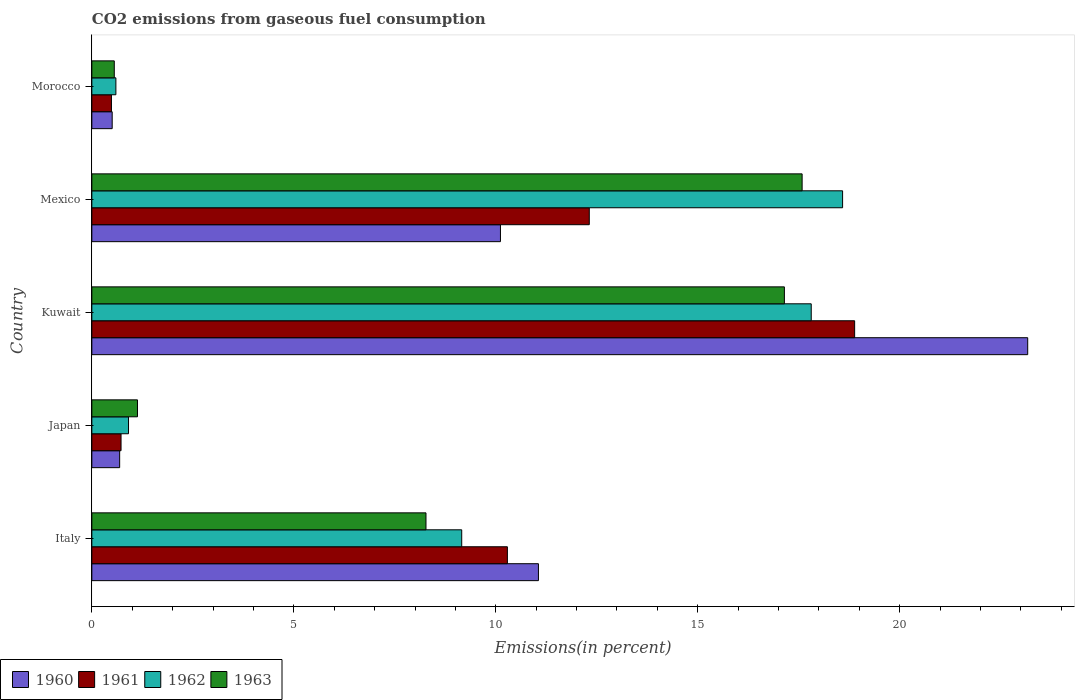How many bars are there on the 2nd tick from the bottom?
Give a very brief answer. 4. What is the label of the 2nd group of bars from the top?
Make the answer very short. Mexico. In how many cases, is the number of bars for a given country not equal to the number of legend labels?
Your response must be concise. 0. What is the total CO2 emitted in 1963 in Mexico?
Make the answer very short. 17.58. Across all countries, what is the maximum total CO2 emitted in 1960?
Keep it short and to the point. 23.17. Across all countries, what is the minimum total CO2 emitted in 1961?
Offer a very short reply. 0.49. In which country was the total CO2 emitted in 1962 minimum?
Ensure brevity in your answer.  Morocco. What is the total total CO2 emitted in 1960 in the graph?
Your response must be concise. 45.53. What is the difference between the total CO2 emitted in 1962 in Italy and that in Morocco?
Provide a short and direct response. 8.56. What is the difference between the total CO2 emitted in 1961 in Italy and the total CO2 emitted in 1960 in Kuwait?
Ensure brevity in your answer.  -12.88. What is the average total CO2 emitted in 1961 per country?
Ensure brevity in your answer.  8.54. What is the difference between the total CO2 emitted in 1963 and total CO2 emitted in 1962 in Japan?
Offer a very short reply. 0.22. What is the ratio of the total CO2 emitted in 1960 in Italy to that in Morocco?
Ensure brevity in your answer.  21.96. Is the total CO2 emitted in 1960 in Kuwait less than that in Morocco?
Your answer should be compact. No. What is the difference between the highest and the second highest total CO2 emitted in 1963?
Give a very brief answer. 0.44. What is the difference between the highest and the lowest total CO2 emitted in 1963?
Your answer should be very brief. 17.03. Is the sum of the total CO2 emitted in 1962 in Japan and Morocco greater than the maximum total CO2 emitted in 1961 across all countries?
Give a very brief answer. No. Is it the case that in every country, the sum of the total CO2 emitted in 1962 and total CO2 emitted in 1963 is greater than the sum of total CO2 emitted in 1961 and total CO2 emitted in 1960?
Offer a very short reply. No. How many bars are there?
Keep it short and to the point. 20. Are all the bars in the graph horizontal?
Your response must be concise. Yes. How many countries are there in the graph?
Provide a succinct answer. 5. Are the values on the major ticks of X-axis written in scientific E-notation?
Make the answer very short. No. Does the graph contain grids?
Ensure brevity in your answer.  No. Where does the legend appear in the graph?
Ensure brevity in your answer.  Bottom left. How many legend labels are there?
Your answer should be very brief. 4. What is the title of the graph?
Keep it short and to the point. CO2 emissions from gaseous fuel consumption. Does "1967" appear as one of the legend labels in the graph?
Provide a short and direct response. No. What is the label or title of the X-axis?
Offer a very short reply. Emissions(in percent). What is the Emissions(in percent) of 1960 in Italy?
Your answer should be compact. 11.06. What is the Emissions(in percent) in 1961 in Italy?
Your answer should be compact. 10.29. What is the Emissions(in percent) of 1962 in Italy?
Provide a succinct answer. 9.16. What is the Emissions(in percent) of 1963 in Italy?
Keep it short and to the point. 8.27. What is the Emissions(in percent) in 1960 in Japan?
Give a very brief answer. 0.69. What is the Emissions(in percent) of 1961 in Japan?
Your response must be concise. 0.72. What is the Emissions(in percent) in 1962 in Japan?
Provide a succinct answer. 0.91. What is the Emissions(in percent) in 1963 in Japan?
Keep it short and to the point. 1.13. What is the Emissions(in percent) of 1960 in Kuwait?
Provide a short and direct response. 23.17. What is the Emissions(in percent) in 1961 in Kuwait?
Provide a short and direct response. 18.88. What is the Emissions(in percent) of 1962 in Kuwait?
Offer a very short reply. 17.81. What is the Emissions(in percent) of 1963 in Kuwait?
Make the answer very short. 17.14. What is the Emissions(in percent) in 1960 in Mexico?
Offer a very short reply. 10.12. What is the Emissions(in percent) in 1961 in Mexico?
Your answer should be very brief. 12.31. What is the Emissions(in percent) in 1962 in Mexico?
Offer a terse response. 18.59. What is the Emissions(in percent) of 1963 in Mexico?
Provide a short and direct response. 17.58. What is the Emissions(in percent) of 1960 in Morocco?
Your response must be concise. 0.5. What is the Emissions(in percent) in 1961 in Morocco?
Offer a very short reply. 0.49. What is the Emissions(in percent) of 1962 in Morocco?
Offer a terse response. 0.6. What is the Emissions(in percent) of 1963 in Morocco?
Keep it short and to the point. 0.56. Across all countries, what is the maximum Emissions(in percent) in 1960?
Your answer should be very brief. 23.17. Across all countries, what is the maximum Emissions(in percent) in 1961?
Offer a terse response. 18.88. Across all countries, what is the maximum Emissions(in percent) in 1962?
Keep it short and to the point. 18.59. Across all countries, what is the maximum Emissions(in percent) of 1963?
Make the answer very short. 17.58. Across all countries, what is the minimum Emissions(in percent) of 1960?
Keep it short and to the point. 0.5. Across all countries, what is the minimum Emissions(in percent) in 1961?
Offer a very short reply. 0.49. Across all countries, what is the minimum Emissions(in percent) of 1962?
Offer a very short reply. 0.6. Across all countries, what is the minimum Emissions(in percent) of 1963?
Keep it short and to the point. 0.56. What is the total Emissions(in percent) in 1960 in the graph?
Your response must be concise. 45.53. What is the total Emissions(in percent) of 1961 in the graph?
Your response must be concise. 42.69. What is the total Emissions(in percent) of 1962 in the graph?
Your response must be concise. 47.05. What is the total Emissions(in percent) of 1963 in the graph?
Your response must be concise. 44.68. What is the difference between the Emissions(in percent) in 1960 in Italy and that in Japan?
Provide a succinct answer. 10.37. What is the difference between the Emissions(in percent) in 1961 in Italy and that in Japan?
Your response must be concise. 9.56. What is the difference between the Emissions(in percent) in 1962 in Italy and that in Japan?
Your answer should be very brief. 8.25. What is the difference between the Emissions(in percent) of 1963 in Italy and that in Japan?
Your response must be concise. 7.14. What is the difference between the Emissions(in percent) of 1960 in Italy and that in Kuwait?
Your answer should be compact. -12.11. What is the difference between the Emissions(in percent) in 1961 in Italy and that in Kuwait?
Make the answer very short. -8.6. What is the difference between the Emissions(in percent) in 1962 in Italy and that in Kuwait?
Your response must be concise. -8.65. What is the difference between the Emissions(in percent) of 1963 in Italy and that in Kuwait?
Your answer should be compact. -8.87. What is the difference between the Emissions(in percent) in 1960 in Italy and that in Mexico?
Give a very brief answer. 0.94. What is the difference between the Emissions(in percent) in 1961 in Italy and that in Mexico?
Offer a terse response. -2.03. What is the difference between the Emissions(in percent) of 1962 in Italy and that in Mexico?
Provide a short and direct response. -9.43. What is the difference between the Emissions(in percent) in 1963 in Italy and that in Mexico?
Make the answer very short. -9.31. What is the difference between the Emissions(in percent) of 1960 in Italy and that in Morocco?
Provide a succinct answer. 10.55. What is the difference between the Emissions(in percent) in 1961 in Italy and that in Morocco?
Your answer should be compact. 9.8. What is the difference between the Emissions(in percent) in 1962 in Italy and that in Morocco?
Your response must be concise. 8.56. What is the difference between the Emissions(in percent) in 1963 in Italy and that in Morocco?
Your answer should be very brief. 7.72. What is the difference between the Emissions(in percent) of 1960 in Japan and that in Kuwait?
Keep it short and to the point. -22.48. What is the difference between the Emissions(in percent) in 1961 in Japan and that in Kuwait?
Provide a short and direct response. -18.16. What is the difference between the Emissions(in percent) in 1962 in Japan and that in Kuwait?
Make the answer very short. -16.9. What is the difference between the Emissions(in percent) of 1963 in Japan and that in Kuwait?
Provide a succinct answer. -16.01. What is the difference between the Emissions(in percent) of 1960 in Japan and that in Mexico?
Give a very brief answer. -9.43. What is the difference between the Emissions(in percent) in 1961 in Japan and that in Mexico?
Provide a short and direct response. -11.59. What is the difference between the Emissions(in percent) of 1962 in Japan and that in Mexico?
Offer a very short reply. -17.68. What is the difference between the Emissions(in percent) of 1963 in Japan and that in Mexico?
Your response must be concise. -16.45. What is the difference between the Emissions(in percent) in 1960 in Japan and that in Morocco?
Give a very brief answer. 0.18. What is the difference between the Emissions(in percent) in 1961 in Japan and that in Morocco?
Your response must be concise. 0.24. What is the difference between the Emissions(in percent) of 1962 in Japan and that in Morocco?
Your answer should be compact. 0.31. What is the difference between the Emissions(in percent) in 1963 in Japan and that in Morocco?
Your answer should be very brief. 0.57. What is the difference between the Emissions(in percent) of 1960 in Kuwait and that in Mexico?
Your answer should be compact. 13.05. What is the difference between the Emissions(in percent) in 1961 in Kuwait and that in Mexico?
Ensure brevity in your answer.  6.57. What is the difference between the Emissions(in percent) of 1962 in Kuwait and that in Mexico?
Make the answer very short. -0.78. What is the difference between the Emissions(in percent) of 1963 in Kuwait and that in Mexico?
Make the answer very short. -0.44. What is the difference between the Emissions(in percent) of 1960 in Kuwait and that in Morocco?
Offer a terse response. 22.66. What is the difference between the Emissions(in percent) of 1961 in Kuwait and that in Morocco?
Give a very brief answer. 18.4. What is the difference between the Emissions(in percent) in 1962 in Kuwait and that in Morocco?
Keep it short and to the point. 17.21. What is the difference between the Emissions(in percent) of 1963 in Kuwait and that in Morocco?
Keep it short and to the point. 16.59. What is the difference between the Emissions(in percent) of 1960 in Mexico and that in Morocco?
Your answer should be compact. 9.61. What is the difference between the Emissions(in percent) of 1961 in Mexico and that in Morocco?
Provide a succinct answer. 11.83. What is the difference between the Emissions(in percent) of 1962 in Mexico and that in Morocco?
Your response must be concise. 17.99. What is the difference between the Emissions(in percent) in 1963 in Mexico and that in Morocco?
Give a very brief answer. 17.03. What is the difference between the Emissions(in percent) of 1960 in Italy and the Emissions(in percent) of 1961 in Japan?
Make the answer very short. 10.33. What is the difference between the Emissions(in percent) of 1960 in Italy and the Emissions(in percent) of 1962 in Japan?
Keep it short and to the point. 10.15. What is the difference between the Emissions(in percent) in 1960 in Italy and the Emissions(in percent) in 1963 in Japan?
Your response must be concise. 9.93. What is the difference between the Emissions(in percent) of 1961 in Italy and the Emissions(in percent) of 1962 in Japan?
Give a very brief answer. 9.38. What is the difference between the Emissions(in percent) in 1961 in Italy and the Emissions(in percent) in 1963 in Japan?
Make the answer very short. 9.16. What is the difference between the Emissions(in percent) of 1962 in Italy and the Emissions(in percent) of 1963 in Japan?
Your response must be concise. 8.03. What is the difference between the Emissions(in percent) in 1960 in Italy and the Emissions(in percent) in 1961 in Kuwait?
Your answer should be very brief. -7.83. What is the difference between the Emissions(in percent) in 1960 in Italy and the Emissions(in percent) in 1962 in Kuwait?
Provide a succinct answer. -6.75. What is the difference between the Emissions(in percent) of 1960 in Italy and the Emissions(in percent) of 1963 in Kuwait?
Give a very brief answer. -6.09. What is the difference between the Emissions(in percent) of 1961 in Italy and the Emissions(in percent) of 1962 in Kuwait?
Your response must be concise. -7.52. What is the difference between the Emissions(in percent) of 1961 in Italy and the Emissions(in percent) of 1963 in Kuwait?
Your answer should be very brief. -6.86. What is the difference between the Emissions(in percent) of 1962 in Italy and the Emissions(in percent) of 1963 in Kuwait?
Provide a succinct answer. -7.99. What is the difference between the Emissions(in percent) of 1960 in Italy and the Emissions(in percent) of 1961 in Mexico?
Keep it short and to the point. -1.26. What is the difference between the Emissions(in percent) in 1960 in Italy and the Emissions(in percent) in 1962 in Mexico?
Offer a very short reply. -7.53. What is the difference between the Emissions(in percent) in 1960 in Italy and the Emissions(in percent) in 1963 in Mexico?
Provide a succinct answer. -6.53. What is the difference between the Emissions(in percent) in 1961 in Italy and the Emissions(in percent) in 1962 in Mexico?
Your answer should be compact. -8.3. What is the difference between the Emissions(in percent) of 1961 in Italy and the Emissions(in percent) of 1963 in Mexico?
Make the answer very short. -7.3. What is the difference between the Emissions(in percent) of 1962 in Italy and the Emissions(in percent) of 1963 in Mexico?
Your answer should be compact. -8.43. What is the difference between the Emissions(in percent) of 1960 in Italy and the Emissions(in percent) of 1961 in Morocco?
Your answer should be compact. 10.57. What is the difference between the Emissions(in percent) in 1960 in Italy and the Emissions(in percent) in 1962 in Morocco?
Keep it short and to the point. 10.46. What is the difference between the Emissions(in percent) of 1961 in Italy and the Emissions(in percent) of 1962 in Morocco?
Your response must be concise. 9.69. What is the difference between the Emissions(in percent) of 1961 in Italy and the Emissions(in percent) of 1963 in Morocco?
Provide a short and direct response. 9.73. What is the difference between the Emissions(in percent) of 1962 in Italy and the Emissions(in percent) of 1963 in Morocco?
Offer a very short reply. 8.6. What is the difference between the Emissions(in percent) in 1960 in Japan and the Emissions(in percent) in 1961 in Kuwait?
Provide a short and direct response. -18.19. What is the difference between the Emissions(in percent) in 1960 in Japan and the Emissions(in percent) in 1962 in Kuwait?
Provide a succinct answer. -17.12. What is the difference between the Emissions(in percent) of 1960 in Japan and the Emissions(in percent) of 1963 in Kuwait?
Your response must be concise. -16.46. What is the difference between the Emissions(in percent) of 1961 in Japan and the Emissions(in percent) of 1962 in Kuwait?
Your response must be concise. -17.09. What is the difference between the Emissions(in percent) in 1961 in Japan and the Emissions(in percent) in 1963 in Kuwait?
Provide a short and direct response. -16.42. What is the difference between the Emissions(in percent) of 1962 in Japan and the Emissions(in percent) of 1963 in Kuwait?
Provide a succinct answer. -16.24. What is the difference between the Emissions(in percent) of 1960 in Japan and the Emissions(in percent) of 1961 in Mexico?
Your answer should be very brief. -11.63. What is the difference between the Emissions(in percent) in 1960 in Japan and the Emissions(in percent) in 1962 in Mexico?
Offer a terse response. -17.9. What is the difference between the Emissions(in percent) of 1960 in Japan and the Emissions(in percent) of 1963 in Mexico?
Provide a succinct answer. -16.89. What is the difference between the Emissions(in percent) of 1961 in Japan and the Emissions(in percent) of 1962 in Mexico?
Make the answer very short. -17.86. What is the difference between the Emissions(in percent) of 1961 in Japan and the Emissions(in percent) of 1963 in Mexico?
Your response must be concise. -16.86. What is the difference between the Emissions(in percent) in 1962 in Japan and the Emissions(in percent) in 1963 in Mexico?
Offer a terse response. -16.68. What is the difference between the Emissions(in percent) in 1960 in Japan and the Emissions(in percent) in 1961 in Morocco?
Ensure brevity in your answer.  0.2. What is the difference between the Emissions(in percent) of 1960 in Japan and the Emissions(in percent) of 1962 in Morocco?
Make the answer very short. 0.09. What is the difference between the Emissions(in percent) of 1960 in Japan and the Emissions(in percent) of 1963 in Morocco?
Ensure brevity in your answer.  0.13. What is the difference between the Emissions(in percent) of 1961 in Japan and the Emissions(in percent) of 1962 in Morocco?
Keep it short and to the point. 0.13. What is the difference between the Emissions(in percent) in 1961 in Japan and the Emissions(in percent) in 1963 in Morocco?
Offer a very short reply. 0.17. What is the difference between the Emissions(in percent) of 1962 in Japan and the Emissions(in percent) of 1963 in Morocco?
Keep it short and to the point. 0.35. What is the difference between the Emissions(in percent) of 1960 in Kuwait and the Emissions(in percent) of 1961 in Mexico?
Make the answer very short. 10.85. What is the difference between the Emissions(in percent) of 1960 in Kuwait and the Emissions(in percent) of 1962 in Mexico?
Keep it short and to the point. 4.58. What is the difference between the Emissions(in percent) of 1960 in Kuwait and the Emissions(in percent) of 1963 in Mexico?
Give a very brief answer. 5.58. What is the difference between the Emissions(in percent) in 1961 in Kuwait and the Emissions(in percent) in 1962 in Mexico?
Provide a short and direct response. 0.3. What is the difference between the Emissions(in percent) of 1961 in Kuwait and the Emissions(in percent) of 1963 in Mexico?
Give a very brief answer. 1.3. What is the difference between the Emissions(in percent) of 1962 in Kuwait and the Emissions(in percent) of 1963 in Mexico?
Ensure brevity in your answer.  0.23. What is the difference between the Emissions(in percent) of 1960 in Kuwait and the Emissions(in percent) of 1961 in Morocco?
Provide a short and direct response. 22.68. What is the difference between the Emissions(in percent) in 1960 in Kuwait and the Emissions(in percent) in 1962 in Morocco?
Make the answer very short. 22.57. What is the difference between the Emissions(in percent) in 1960 in Kuwait and the Emissions(in percent) in 1963 in Morocco?
Your response must be concise. 22.61. What is the difference between the Emissions(in percent) in 1961 in Kuwait and the Emissions(in percent) in 1962 in Morocco?
Provide a short and direct response. 18.29. What is the difference between the Emissions(in percent) in 1961 in Kuwait and the Emissions(in percent) in 1963 in Morocco?
Ensure brevity in your answer.  18.33. What is the difference between the Emissions(in percent) of 1962 in Kuwait and the Emissions(in percent) of 1963 in Morocco?
Ensure brevity in your answer.  17.25. What is the difference between the Emissions(in percent) of 1960 in Mexico and the Emissions(in percent) of 1961 in Morocco?
Provide a short and direct response. 9.63. What is the difference between the Emissions(in percent) of 1960 in Mexico and the Emissions(in percent) of 1962 in Morocco?
Ensure brevity in your answer.  9.52. What is the difference between the Emissions(in percent) in 1960 in Mexico and the Emissions(in percent) in 1963 in Morocco?
Your answer should be very brief. 9.56. What is the difference between the Emissions(in percent) of 1961 in Mexico and the Emissions(in percent) of 1962 in Morocco?
Make the answer very short. 11.72. What is the difference between the Emissions(in percent) in 1961 in Mexico and the Emissions(in percent) in 1963 in Morocco?
Offer a terse response. 11.76. What is the difference between the Emissions(in percent) of 1962 in Mexico and the Emissions(in percent) of 1963 in Morocco?
Your answer should be compact. 18.03. What is the average Emissions(in percent) in 1960 per country?
Keep it short and to the point. 9.11. What is the average Emissions(in percent) of 1961 per country?
Your response must be concise. 8.54. What is the average Emissions(in percent) of 1962 per country?
Your answer should be compact. 9.41. What is the average Emissions(in percent) in 1963 per country?
Make the answer very short. 8.94. What is the difference between the Emissions(in percent) in 1960 and Emissions(in percent) in 1961 in Italy?
Provide a succinct answer. 0.77. What is the difference between the Emissions(in percent) of 1960 and Emissions(in percent) of 1962 in Italy?
Ensure brevity in your answer.  1.9. What is the difference between the Emissions(in percent) in 1960 and Emissions(in percent) in 1963 in Italy?
Provide a succinct answer. 2.78. What is the difference between the Emissions(in percent) in 1961 and Emissions(in percent) in 1962 in Italy?
Your answer should be very brief. 1.13. What is the difference between the Emissions(in percent) in 1961 and Emissions(in percent) in 1963 in Italy?
Make the answer very short. 2.02. What is the difference between the Emissions(in percent) in 1962 and Emissions(in percent) in 1963 in Italy?
Your response must be concise. 0.88. What is the difference between the Emissions(in percent) of 1960 and Emissions(in percent) of 1961 in Japan?
Your answer should be compact. -0.03. What is the difference between the Emissions(in percent) in 1960 and Emissions(in percent) in 1962 in Japan?
Provide a succinct answer. -0.22. What is the difference between the Emissions(in percent) of 1960 and Emissions(in percent) of 1963 in Japan?
Offer a terse response. -0.44. What is the difference between the Emissions(in percent) in 1961 and Emissions(in percent) in 1962 in Japan?
Your answer should be very brief. -0.19. What is the difference between the Emissions(in percent) in 1961 and Emissions(in percent) in 1963 in Japan?
Provide a short and direct response. -0.41. What is the difference between the Emissions(in percent) of 1962 and Emissions(in percent) of 1963 in Japan?
Offer a very short reply. -0.22. What is the difference between the Emissions(in percent) in 1960 and Emissions(in percent) in 1961 in Kuwait?
Make the answer very short. 4.28. What is the difference between the Emissions(in percent) of 1960 and Emissions(in percent) of 1962 in Kuwait?
Provide a short and direct response. 5.36. What is the difference between the Emissions(in percent) of 1960 and Emissions(in percent) of 1963 in Kuwait?
Your response must be concise. 6.02. What is the difference between the Emissions(in percent) of 1961 and Emissions(in percent) of 1962 in Kuwait?
Your answer should be very brief. 1.07. What is the difference between the Emissions(in percent) in 1961 and Emissions(in percent) in 1963 in Kuwait?
Your answer should be compact. 1.74. What is the difference between the Emissions(in percent) in 1962 and Emissions(in percent) in 1963 in Kuwait?
Make the answer very short. 0.66. What is the difference between the Emissions(in percent) in 1960 and Emissions(in percent) in 1961 in Mexico?
Ensure brevity in your answer.  -2.2. What is the difference between the Emissions(in percent) of 1960 and Emissions(in percent) of 1962 in Mexico?
Provide a short and direct response. -8.47. What is the difference between the Emissions(in percent) in 1960 and Emissions(in percent) in 1963 in Mexico?
Make the answer very short. -7.47. What is the difference between the Emissions(in percent) of 1961 and Emissions(in percent) of 1962 in Mexico?
Give a very brief answer. -6.27. What is the difference between the Emissions(in percent) in 1961 and Emissions(in percent) in 1963 in Mexico?
Your response must be concise. -5.27. What is the difference between the Emissions(in percent) of 1962 and Emissions(in percent) of 1963 in Mexico?
Offer a very short reply. 1. What is the difference between the Emissions(in percent) in 1960 and Emissions(in percent) in 1961 in Morocco?
Offer a very short reply. 0.02. What is the difference between the Emissions(in percent) in 1960 and Emissions(in percent) in 1962 in Morocco?
Offer a terse response. -0.09. What is the difference between the Emissions(in percent) of 1960 and Emissions(in percent) of 1963 in Morocco?
Provide a succinct answer. -0.05. What is the difference between the Emissions(in percent) in 1961 and Emissions(in percent) in 1962 in Morocco?
Ensure brevity in your answer.  -0.11. What is the difference between the Emissions(in percent) of 1961 and Emissions(in percent) of 1963 in Morocco?
Your answer should be very brief. -0.07. What is the difference between the Emissions(in percent) in 1962 and Emissions(in percent) in 1963 in Morocco?
Your response must be concise. 0.04. What is the ratio of the Emissions(in percent) in 1960 in Italy to that in Japan?
Offer a very short reply. 16.06. What is the ratio of the Emissions(in percent) in 1961 in Italy to that in Japan?
Give a very brief answer. 14.23. What is the ratio of the Emissions(in percent) in 1962 in Italy to that in Japan?
Your response must be concise. 10.09. What is the ratio of the Emissions(in percent) of 1963 in Italy to that in Japan?
Provide a short and direct response. 7.32. What is the ratio of the Emissions(in percent) in 1960 in Italy to that in Kuwait?
Your answer should be very brief. 0.48. What is the ratio of the Emissions(in percent) of 1961 in Italy to that in Kuwait?
Keep it short and to the point. 0.54. What is the ratio of the Emissions(in percent) in 1962 in Italy to that in Kuwait?
Ensure brevity in your answer.  0.51. What is the ratio of the Emissions(in percent) in 1963 in Italy to that in Kuwait?
Offer a terse response. 0.48. What is the ratio of the Emissions(in percent) of 1960 in Italy to that in Mexico?
Ensure brevity in your answer.  1.09. What is the ratio of the Emissions(in percent) of 1961 in Italy to that in Mexico?
Your answer should be very brief. 0.84. What is the ratio of the Emissions(in percent) in 1962 in Italy to that in Mexico?
Your answer should be compact. 0.49. What is the ratio of the Emissions(in percent) in 1963 in Italy to that in Mexico?
Provide a succinct answer. 0.47. What is the ratio of the Emissions(in percent) in 1960 in Italy to that in Morocco?
Provide a short and direct response. 21.96. What is the ratio of the Emissions(in percent) in 1961 in Italy to that in Morocco?
Give a very brief answer. 21.19. What is the ratio of the Emissions(in percent) in 1962 in Italy to that in Morocco?
Offer a terse response. 15.38. What is the ratio of the Emissions(in percent) of 1963 in Italy to that in Morocco?
Offer a very short reply. 14.89. What is the ratio of the Emissions(in percent) of 1960 in Japan to that in Kuwait?
Provide a short and direct response. 0.03. What is the ratio of the Emissions(in percent) of 1961 in Japan to that in Kuwait?
Ensure brevity in your answer.  0.04. What is the ratio of the Emissions(in percent) in 1962 in Japan to that in Kuwait?
Provide a short and direct response. 0.05. What is the ratio of the Emissions(in percent) in 1963 in Japan to that in Kuwait?
Offer a terse response. 0.07. What is the ratio of the Emissions(in percent) in 1960 in Japan to that in Mexico?
Give a very brief answer. 0.07. What is the ratio of the Emissions(in percent) in 1961 in Japan to that in Mexico?
Offer a very short reply. 0.06. What is the ratio of the Emissions(in percent) of 1962 in Japan to that in Mexico?
Give a very brief answer. 0.05. What is the ratio of the Emissions(in percent) in 1963 in Japan to that in Mexico?
Offer a very short reply. 0.06. What is the ratio of the Emissions(in percent) of 1960 in Japan to that in Morocco?
Your answer should be compact. 1.37. What is the ratio of the Emissions(in percent) in 1961 in Japan to that in Morocco?
Provide a succinct answer. 1.49. What is the ratio of the Emissions(in percent) of 1962 in Japan to that in Morocco?
Offer a very short reply. 1.53. What is the ratio of the Emissions(in percent) in 1963 in Japan to that in Morocco?
Your response must be concise. 2.03. What is the ratio of the Emissions(in percent) in 1960 in Kuwait to that in Mexico?
Provide a short and direct response. 2.29. What is the ratio of the Emissions(in percent) in 1961 in Kuwait to that in Mexico?
Give a very brief answer. 1.53. What is the ratio of the Emissions(in percent) in 1962 in Kuwait to that in Mexico?
Offer a very short reply. 0.96. What is the ratio of the Emissions(in percent) in 1963 in Kuwait to that in Mexico?
Your response must be concise. 0.97. What is the ratio of the Emissions(in percent) of 1960 in Kuwait to that in Morocco?
Make the answer very short. 46.01. What is the ratio of the Emissions(in percent) in 1961 in Kuwait to that in Morocco?
Your answer should be very brief. 38.9. What is the ratio of the Emissions(in percent) of 1962 in Kuwait to that in Morocco?
Offer a very short reply. 29.92. What is the ratio of the Emissions(in percent) in 1963 in Kuwait to that in Morocco?
Offer a terse response. 30.86. What is the ratio of the Emissions(in percent) in 1960 in Mexico to that in Morocco?
Provide a succinct answer. 20.09. What is the ratio of the Emissions(in percent) in 1961 in Mexico to that in Morocco?
Provide a short and direct response. 25.37. What is the ratio of the Emissions(in percent) of 1962 in Mexico to that in Morocco?
Make the answer very short. 31.22. What is the ratio of the Emissions(in percent) of 1963 in Mexico to that in Morocco?
Provide a succinct answer. 31.65. What is the difference between the highest and the second highest Emissions(in percent) in 1960?
Make the answer very short. 12.11. What is the difference between the highest and the second highest Emissions(in percent) in 1961?
Give a very brief answer. 6.57. What is the difference between the highest and the second highest Emissions(in percent) of 1962?
Provide a short and direct response. 0.78. What is the difference between the highest and the second highest Emissions(in percent) of 1963?
Keep it short and to the point. 0.44. What is the difference between the highest and the lowest Emissions(in percent) of 1960?
Keep it short and to the point. 22.66. What is the difference between the highest and the lowest Emissions(in percent) of 1961?
Provide a succinct answer. 18.4. What is the difference between the highest and the lowest Emissions(in percent) in 1962?
Your answer should be very brief. 17.99. What is the difference between the highest and the lowest Emissions(in percent) in 1963?
Keep it short and to the point. 17.03. 